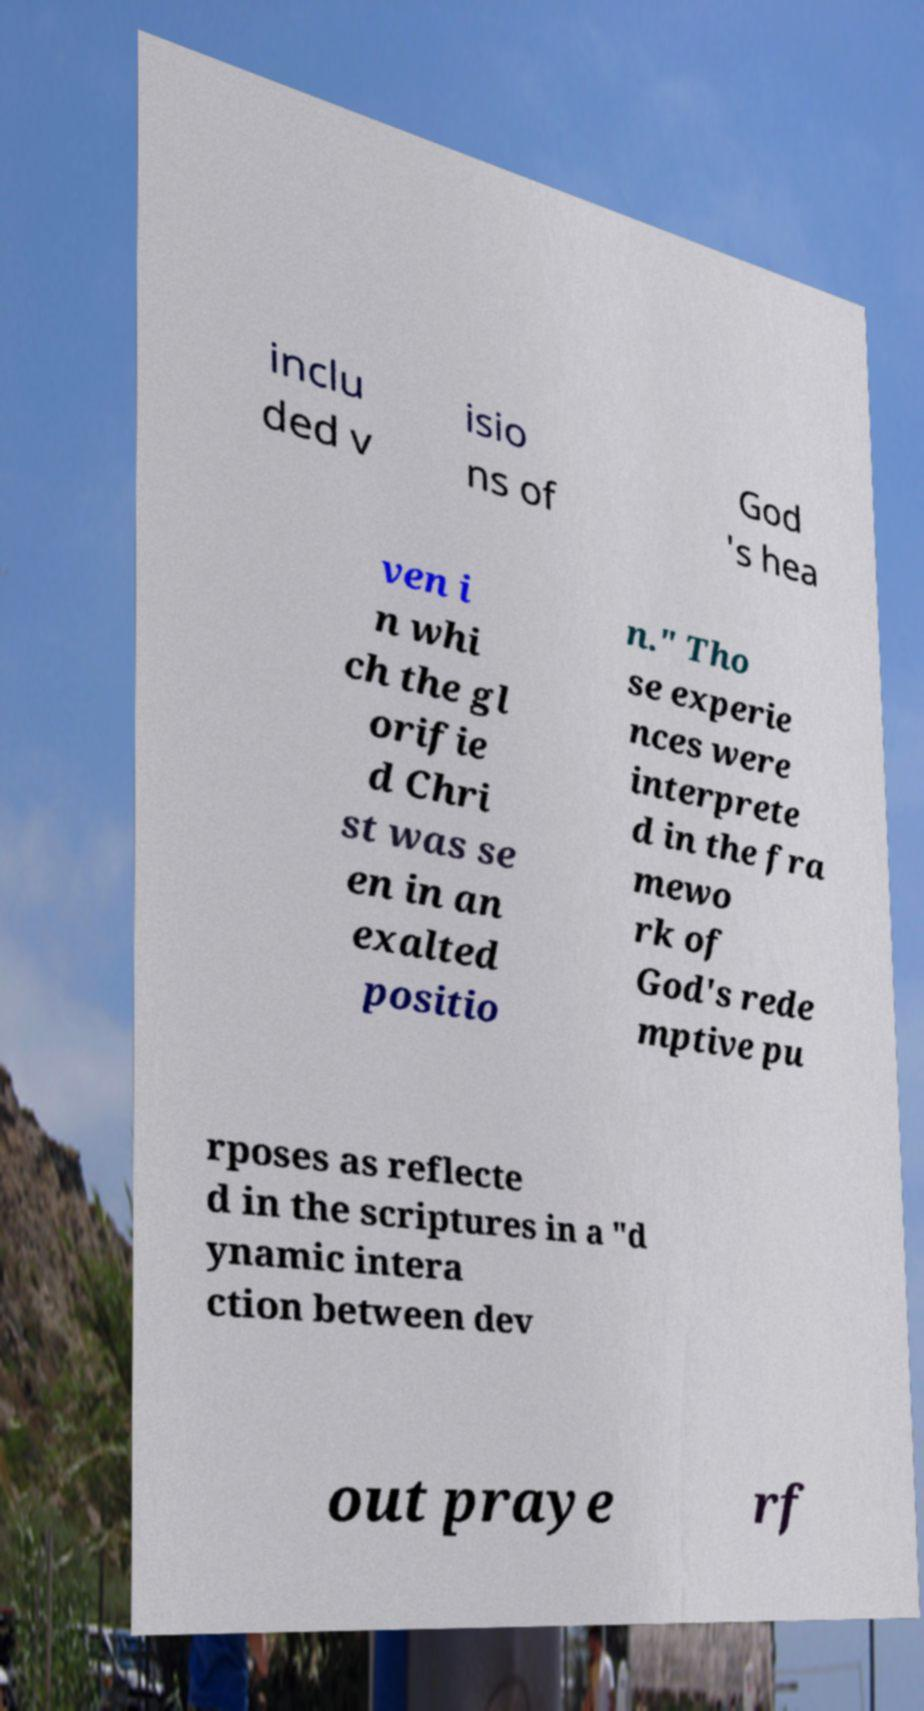There's text embedded in this image that I need extracted. Can you transcribe it verbatim? inclu ded v isio ns of God 's hea ven i n whi ch the gl orifie d Chri st was se en in an exalted positio n." Tho se experie nces were interprete d in the fra mewo rk of God's rede mptive pu rposes as reflecte d in the scriptures in a "d ynamic intera ction between dev out praye rf 